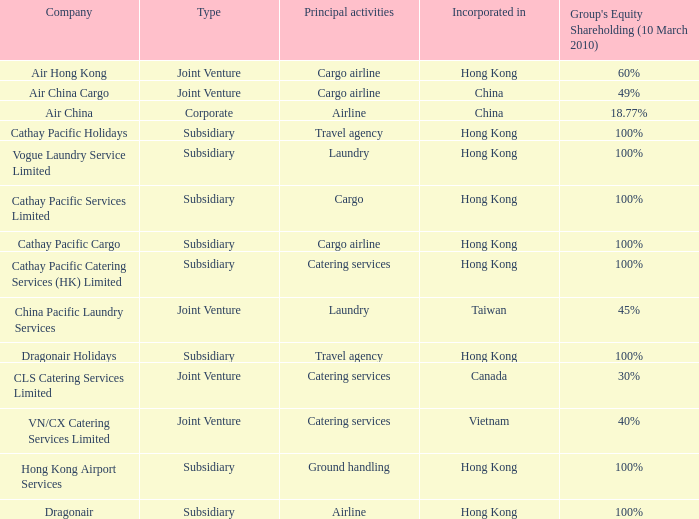Could you parse the entire table? {'header': ['Company', 'Type', 'Principal activities', 'Incorporated in', "Group's Equity Shareholding (10 March 2010)"], 'rows': [['Air Hong Kong', 'Joint Venture', 'Cargo airline', 'Hong Kong', '60%'], ['Air China Cargo', 'Joint Venture', 'Cargo airline', 'China', '49%'], ['Air China', 'Corporate', 'Airline', 'China', '18.77%'], ['Cathay Pacific Holidays', 'Subsidiary', 'Travel agency', 'Hong Kong', '100%'], ['Vogue Laundry Service Limited', 'Subsidiary', 'Laundry', 'Hong Kong', '100%'], ['Cathay Pacific Services Limited', 'Subsidiary', 'Cargo', 'Hong Kong', '100%'], ['Cathay Pacific Cargo', 'Subsidiary', 'Cargo airline', 'Hong Kong', '100%'], ['Cathay Pacific Catering Services (HK) Limited', 'Subsidiary', 'Catering services', 'Hong Kong', '100%'], ['China Pacific Laundry Services', 'Joint Venture', 'Laundry', 'Taiwan', '45%'], ['Dragonair Holidays', 'Subsidiary', 'Travel agency', 'Hong Kong', '100%'], ['CLS Catering Services Limited', 'Joint Venture', 'Catering services', 'Canada', '30%'], ['VN/CX Catering Services Limited', 'Joint Venture', 'Catering services', 'Vietnam', '40%'], ['Hong Kong Airport Services', 'Subsidiary', 'Ground handling', 'Hong Kong', '100%'], ['Dragonair', 'Subsidiary', 'Airline', 'Hong Kong', '100%']]} What is the type for the Cathay Pacific Holidays company, an incorporation of Hong Kong and listed activities as Travel Agency? Subsidiary. 